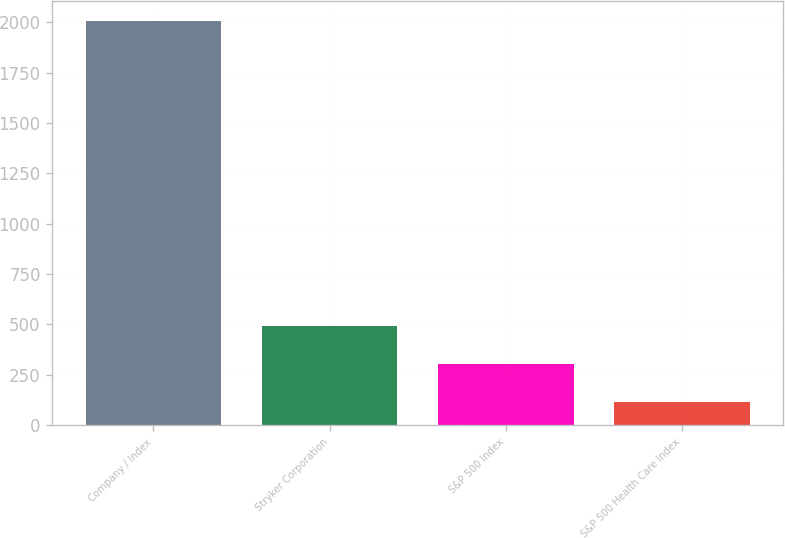Convert chart. <chart><loc_0><loc_0><loc_500><loc_500><bar_chart><fcel>Company / Index<fcel>Stryker Corporation<fcel>S&P 500 Index<fcel>S&P 500 Health Care Index<nl><fcel>2007<fcel>493.58<fcel>304.4<fcel>115.22<nl></chart> 